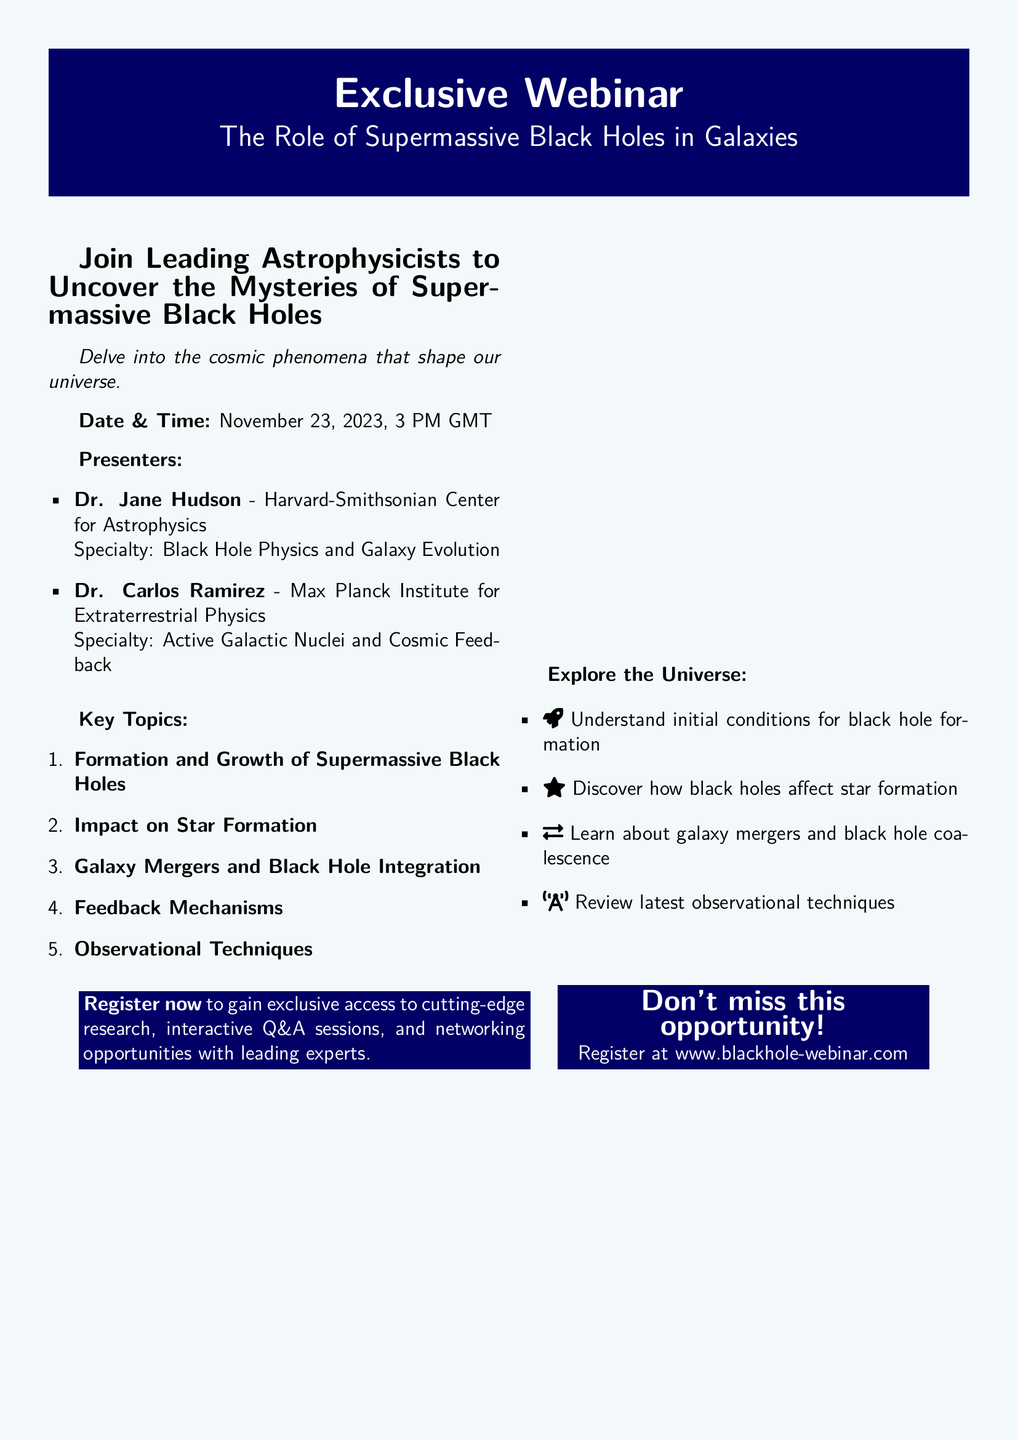What is the date of the webinar? The webinar is scheduled for November 23, 2023.
Answer: November 23, 2023 Who is one of the presenters? The document lists Dr. Jane Hudson and Dr. Carlos Ramirez as presenters.
Answer: Dr. Jane Hudson What is the topic of the webinar? The webinar will cover the role of supermassive black holes in galaxies.
Answer: The Role of Supermassive Black Holes in Galaxies What time is the webinar? The webinar starts at 3 PM GMT.
Answer: 3 PM GMT What is one key topic discussed in the webinar? The document outlines several key topics, one of which is the impact on star formation.
Answer: Impact on Star Formation How many presenters are mentioned? The document mentions two presenters for the webinar.
Answer: Two What is the registration website? The document provides a URL for registration.
Answer: www.blackhole-webinar.com What is the specialty of Dr. Carlos Ramirez? The document states that Dr. Carlos Ramirez specializes in active galactic nuclei and cosmic feedback.
Answer: Active Galactic Nuclei and Cosmic Feedback 